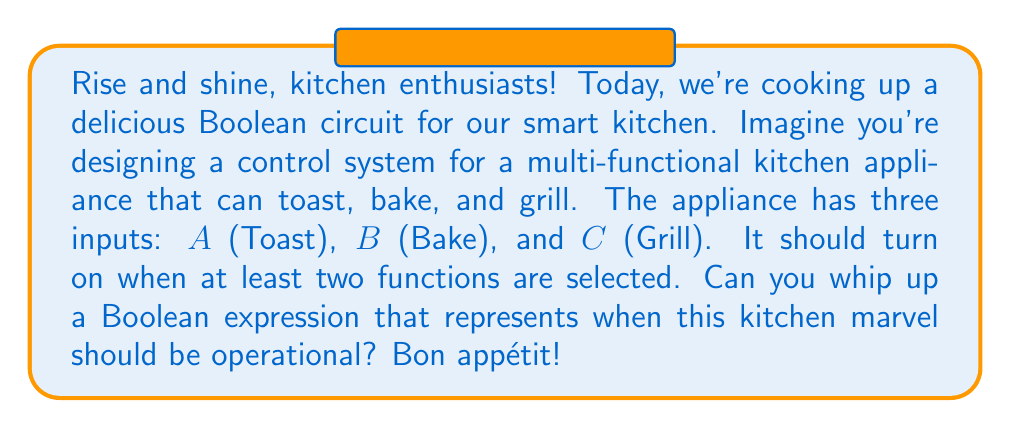Show me your answer to this math problem. Let's break this down step-by-step, just like a perfect recipe:

1) We have three inputs: A (Toast), B (Bake), and C (Grill).

2) The appliance should turn on when at least two functions are selected. This means we need to consider all combinations where two or more inputs are true.

3) Let's list out these combinations:
   - A and B are true (C can be either true or false)
   - A and C are true (B can be either true or false)
   - B and C are true (A can be either true or false)

4) We can represent these combinations using Boolean algebra:
   $$(A \cdot B) + (A \cdot C) + (B \cdot C)$$

5) This expression covers all cases where at least two inputs are true. If all three inputs are true, this expression will still evaluate to true, which is correct for our appliance.

6) We can simplify this further using the distributive law:
   $$A \cdot (B + C) + (B \cdot C)$$

This final expression is our Boolean circuit for the kitchen appliance control system.
Answer: $$A \cdot (B + C) + (B \cdot C)$$ 